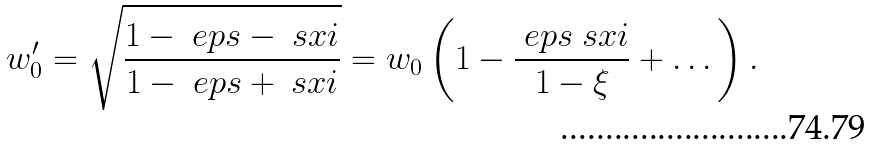Convert formula to latex. <formula><loc_0><loc_0><loc_500><loc_500>w ^ { \prime } _ { 0 } = \sqrt { \frac { 1 - \ e p s - \ s x i } { 1 - \ e p s + \ s x i } } = w _ { 0 } \left ( 1 - \frac { \ e p s \ s x i } { 1 - \xi } + \dots \right ) .</formula> 